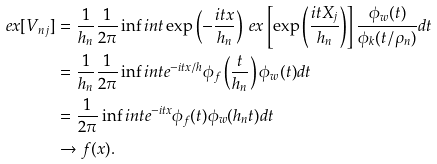<formula> <loc_0><loc_0><loc_500><loc_500>\ e x [ V _ { n j } ] & = \frac { 1 } { h _ { n } } \frac { 1 } { 2 \pi } \inf i n t \exp \left ( - \frac { i { t } x } { h _ { n } } \right ) \ e x \left [ \exp \left ( \frac { i { t } X _ { j } } { h _ { n } } \right ) \right ] \frac { \phi _ { w } ( t ) } { \phi _ { k } ( t / \rho _ { n } ) } d t \\ & = \frac { 1 } { h _ { n } } \frac { 1 } { 2 \pi } \inf i n t e ^ { - i { t } x / h } \phi _ { f } \left ( \frac { t } { h _ { n } } \right ) \phi _ { w } ( t ) d t \\ & = \frac { 1 } { 2 \pi } \inf i n t e ^ { - i { t } x } \phi _ { f } ( { t } ) \phi _ { w } ( h _ { n } t ) d t \\ & \rightarrow f ( x ) .</formula> 